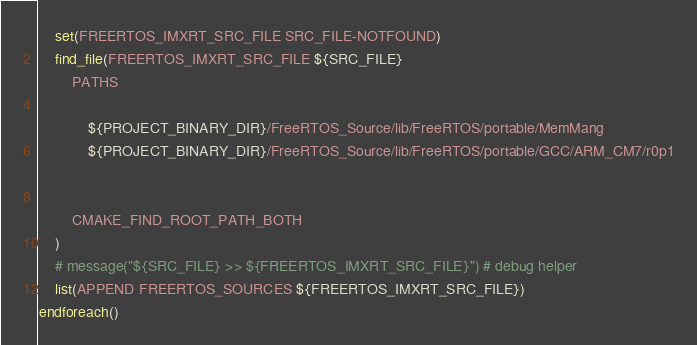Convert code to text. <code><loc_0><loc_0><loc_500><loc_500><_CMake_>    set(FREERTOS_IMXRT_SRC_FILE SRC_FILE-NOTFOUND)
    find_file(FREERTOS_IMXRT_SRC_FILE ${SRC_FILE}
        PATHS 

            ${PROJECT_BINARY_DIR}/FreeRTOS_Source/lib/FreeRTOS/portable/MemMang
            ${PROJECT_BINARY_DIR}/FreeRTOS_Source/lib/FreeRTOS/portable/GCC/ARM_CM7/r0p1
 

        CMAKE_FIND_ROOT_PATH_BOTH
    )
    # message("${SRC_FILE} >> ${FREERTOS_IMXRT_SRC_FILE}") # debug helper
    list(APPEND FREERTOS_SOURCES ${FREERTOS_IMXRT_SRC_FILE})
endforeach()

</code> 